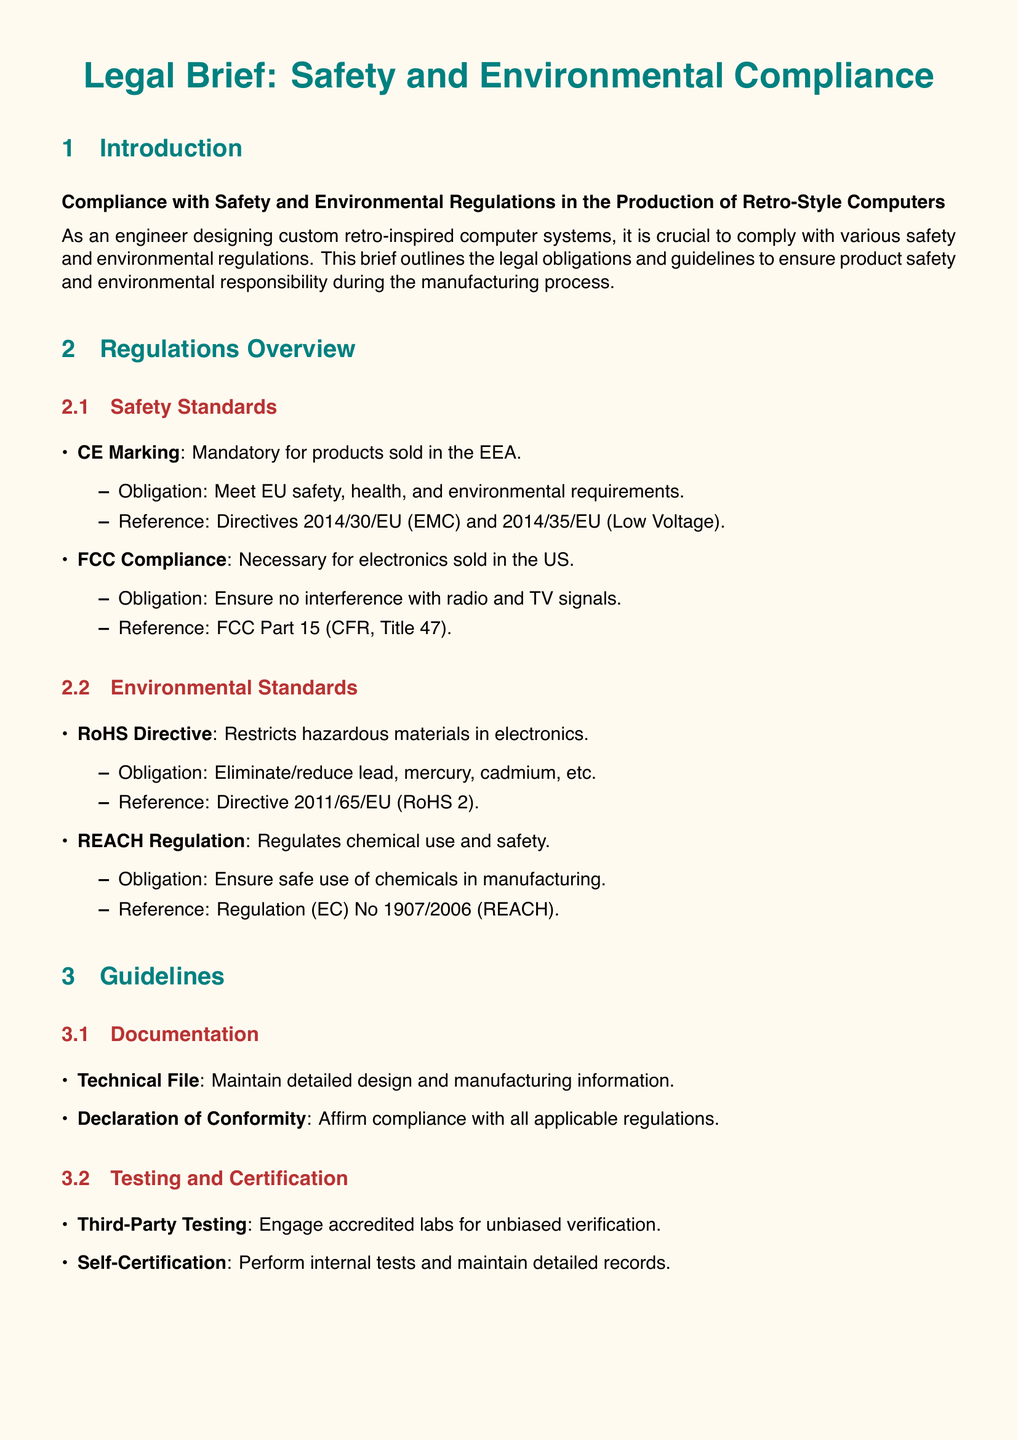What is the title of the legal brief? The title of the legal brief is mentioned prominently at the top of the document.
Answer: Legal Brief: Safety and Environmental Compliance Which directive is referenced for CE Marking? The CE Marking section provides a specific directive reference.
Answer: Directives 2014/30/EU and 2014/35/EU What is the obligation for RoHS Directive? The RoHS Directive section outlines the key obligation regarding hazardous materials.
Answer: Eliminate/reduce lead, mercury, cadmium, etc What does the Declaration of Conformity affirm? The guidelines section describes the purpose of the Declaration of Conformity.
Answer: Compliance with all applicable regulations How many regulations are mentioned under Safety Standards? The regulations overview includes multiple safety standards.
Answer: Two What type of testing is suggested for compliance? The guidelines section indicates a method of testing for compliance.
Answer: Third-Party Testing What are the obligations under REACH Regulation? The REACH Regulation section specifies the obligations associated with chemical safety.
Answer: Ensure safe use of chemicals in manufacturing What must be maintained in a Technical File? The guidelines specify what information should be included in the Technical File.
Answer: Detailed design and manufacturing information Why is adherence to regulations important? The conclusion section emphasizes the significance of adhering to regulations.
Answer: Legal compliance, consumer trust, and product longevity 